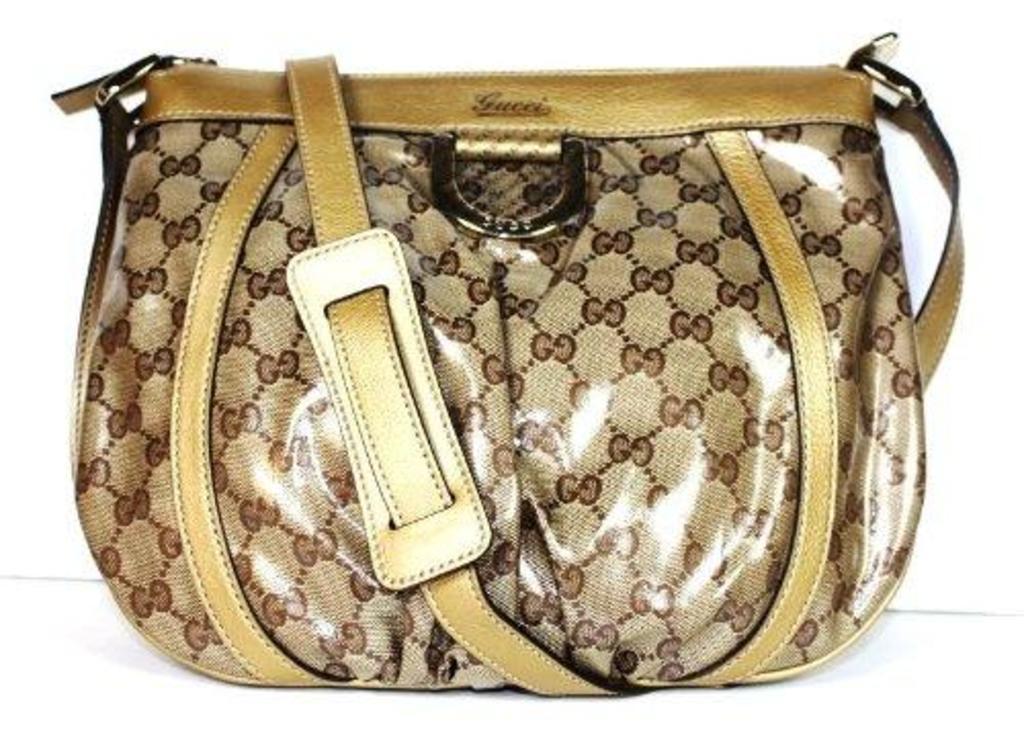Can you describe this image briefly? In this image there is a gold and brown color leather handbag with a holder. 